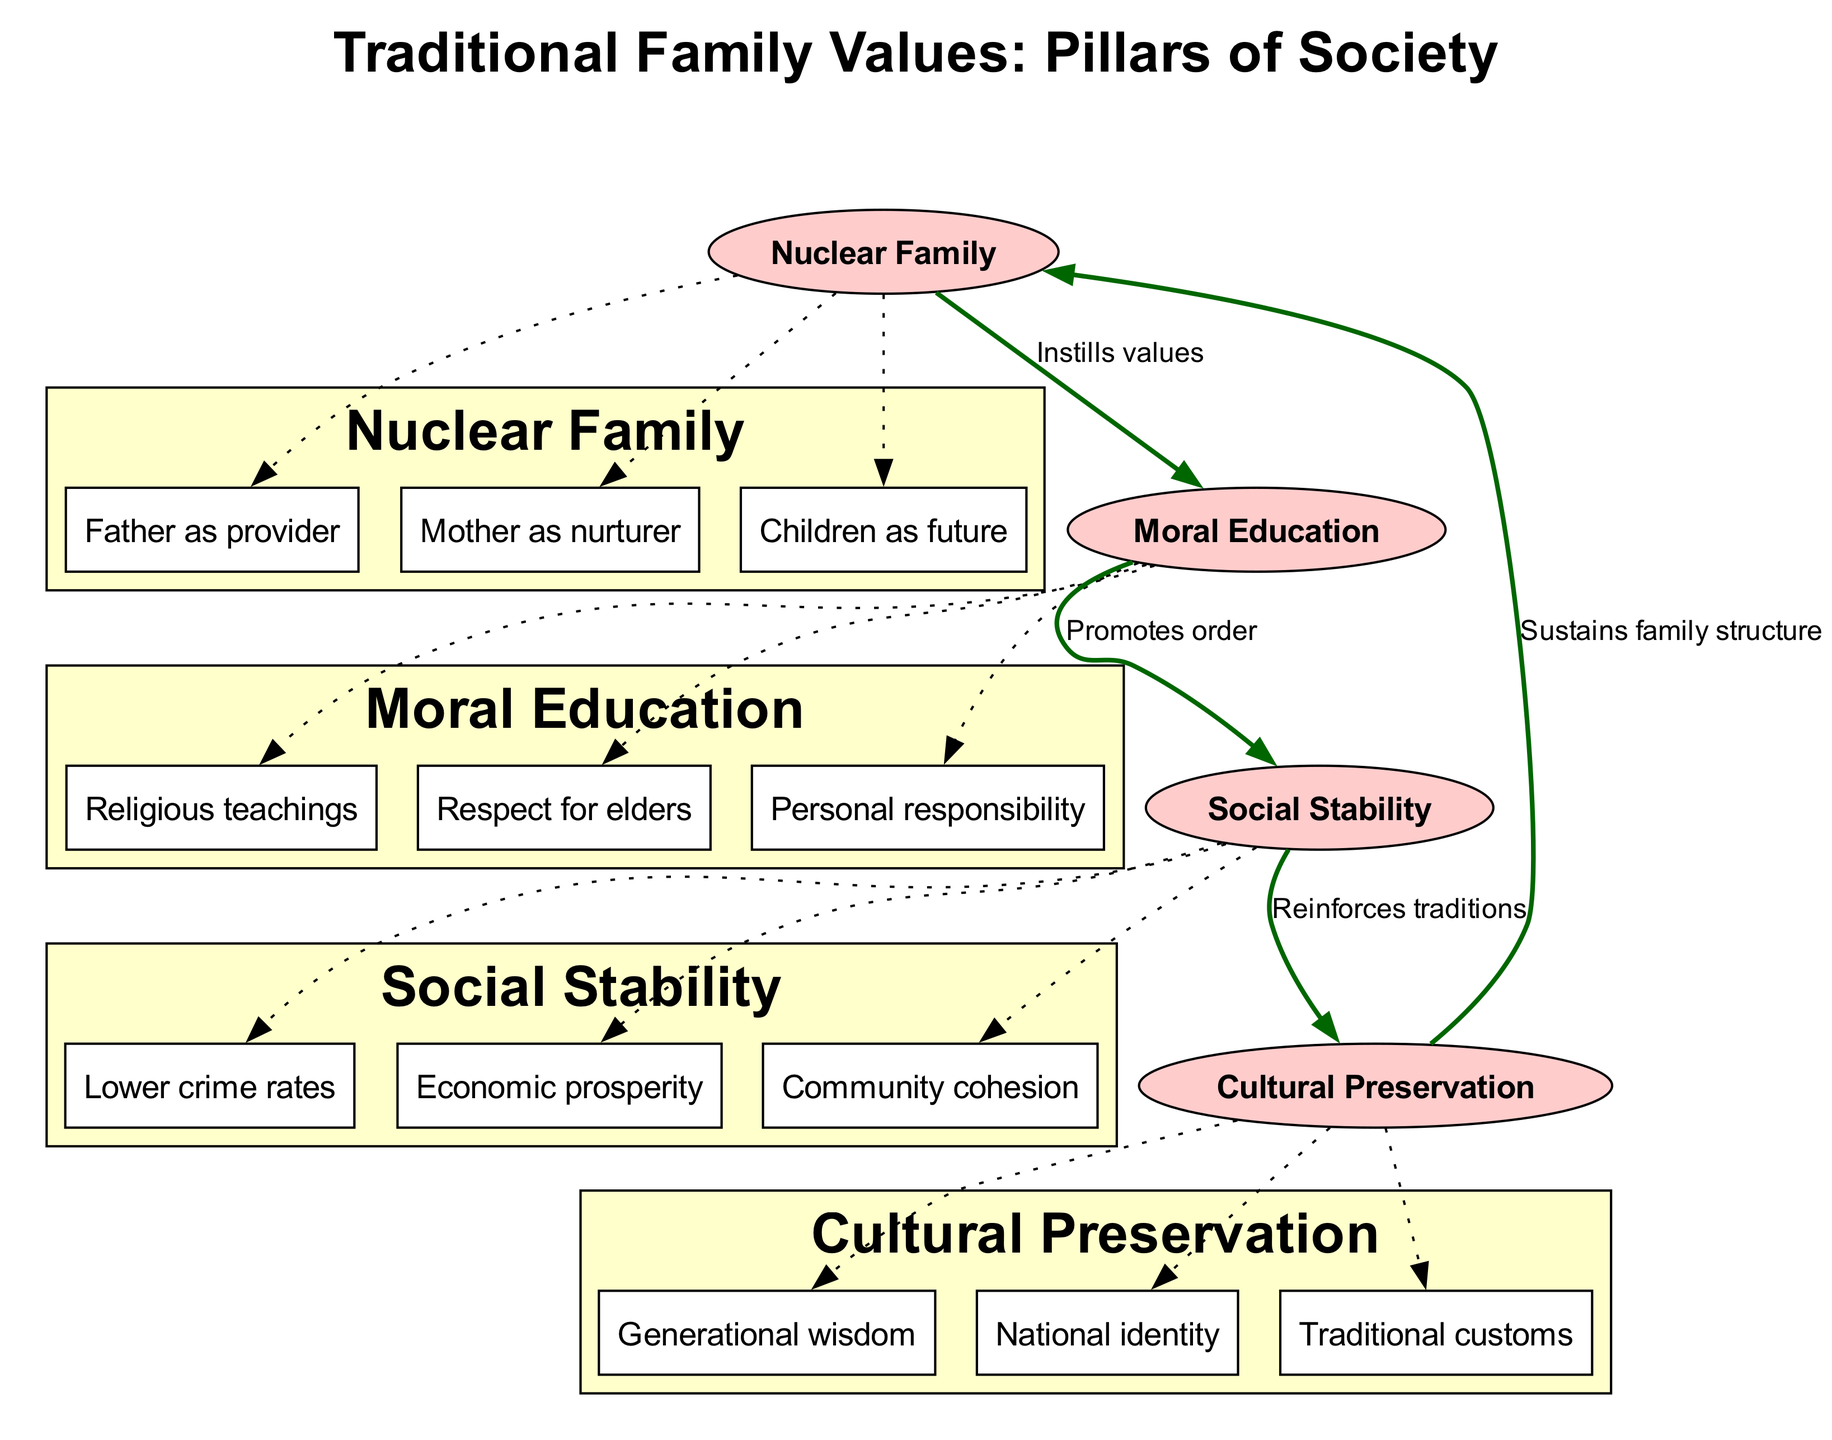What are the main components of the diagram? The diagram contains four main components: Nuclear Family, Moral Education, Social Stability, and Cultural Preservation.
Answer: Nuclear Family, Moral Education, Social Stability, Cultural Preservation How many sub-elements are under "Moral Education"? Under "Moral Education," there are three sub-elements: Religious teachings, Respect for elders, Personal responsibility.
Answer: 3 What does the arrow from "Nuclear Family" to "Moral Education" indicate? The arrow indicates that the Nuclear Family instills values into Moral Education, demonstrating a direct influence relationship.
Answer: Instills values Which component promotes order according to the diagram? The diagram specifies that Moral Education promotes order in society, linking it to social stability.
Answer: Moral Education How does Social Stability relate to Cultural Preservation? The connection shows that Social Stability reinforces traditions, which are part of Cultural Preservation, thereby explaining their relationship.
Answer: Reinforces traditions What is the role of the "Father" in the Nuclear Family? According to the diagram, the Father is portrayed as the provider within the Nuclear Family structure.
Answer: Provider Which two components are connected by the label "Promotes order"? The connection is between "Moral Education" and "Social Stability," indicating that moral teachings help in maintaining societal order.
Answer: Moral Education, Social Stability What does Cultural Preservation sustain according to the diagram? The diagram states that Cultural Preservation sustains the family structure by emphasizing the importance of traditional customs and identity.
Answer: Family structure How many connections are shown in total in the diagram? The diagram features four connections that illustrate relationships between the main components.
Answer: 4 Which element is described as "Children as future"? The element "Children as future" is a sub-element of the "Nuclear Family," highlighting the role of children in family dynamics.
Answer: Children as future 